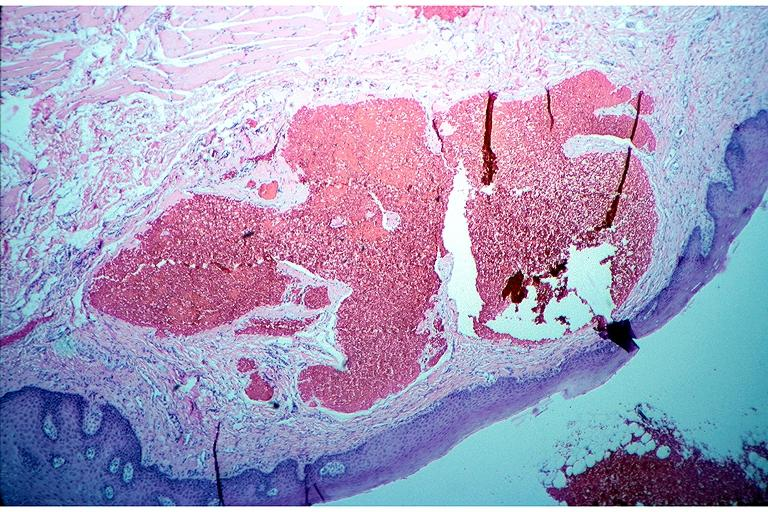s oral present?
Answer the question using a single word or phrase. Yes 